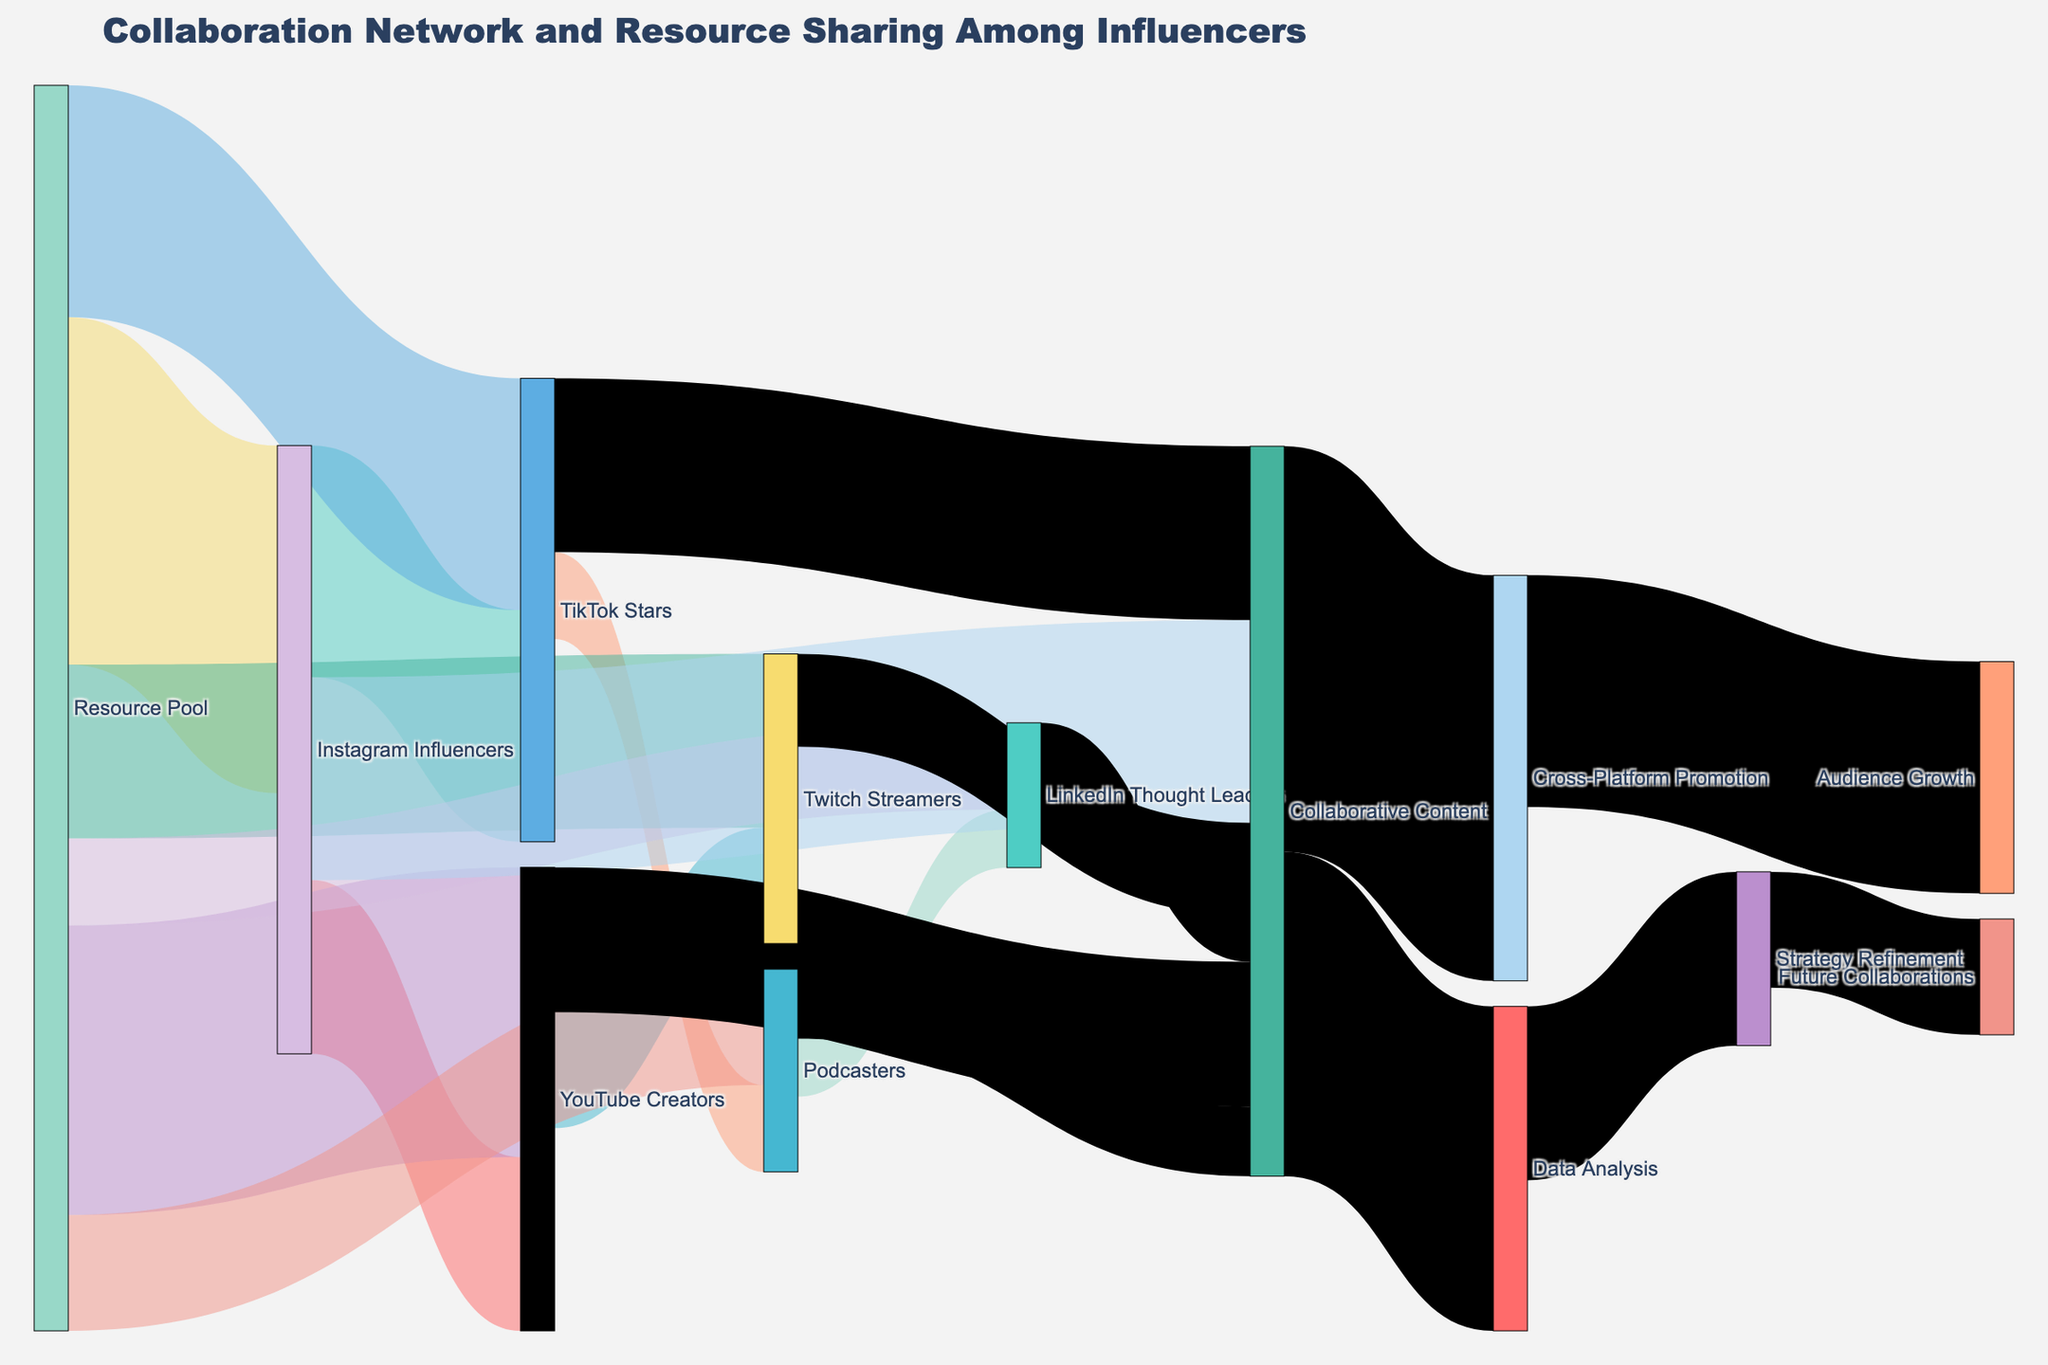How many nodes are involved in the entire collaboration network? To determine the number of nodes, we count all unique entities appearing as either a source or a target. The dataset has 11 unique nodes in total.
Answer: 11 Which influencer group receives the highest resources from the Resource Pool? By examining the links from the Resource Pool, we see that Instagram Influencers receive 300 units, which is the highest amount among all the influencer groups.
Answer: Instagram Influencers How much of the "Collaborative Content" flows into "Data Analysis"? Checking the connections from "Collaborative Content", we note that 280 units are transferred into "Data Analysis".
Answer: 280 What is the total amount of resources distributed from the Resource Pool? Sum the values of all links originating from the Resource Pool: 300 + 250 + 200 + 150 + 100 + 75 = 1075.
Answer: 1075 Which influencer group contributes the highest value to "Collaborative Content"? By observing the connections to "Collaborative Content", we can see that Instagram Influencers contribute 175 units, the highest among all influencer groups.
Answer: Instagram Influencers Compare the flow value of resources from "TikTok Stars" to "Podcasters" with that from "YouTube Creators" to "Twitch Streamers". Resources from TikTok Stars to Podcasters are 75 units, and from YouTube Creators to Twitch Streamers are 100 units. 100 is greater than 75.
Answer: YouTube Creators to Twitch Streamers > TikTok Stars to Podcasters What is the distribution of flows from "Collaborative Content"? Add the flows into "Cross-Platform Promotion" (350) and "Data Analysis" (280). The total flow is 630; distribution percentages are (350/630)*100 ≈ 55.6% and (280/630)*100 ≈ 44.4%.
Answer: ~55.6%, ~44.4% Which node is the most central within the whole network? "Collaborative Content" has the most connections both incoming and outgoing, indicating its central role in the collaboration network.
Answer: Collaborative Content What amount flows from “Cross-Platform Promotion” to “Audience Growth” and what does it represent in terms of percentage of the total collaborative content? The flow is 200 units. The total Collaborative Content is 630 units. So the percentage is (200/630)*100 ≈ 31.75%.
Answer: 31.75% What is the final value flowing into "Future Collaborations"? Following the Sankey path, "Data Analysis" contributes 150 units to "Strategy Refinement", which then passes 100 units to "Future Collaborations".
Answer: 100 